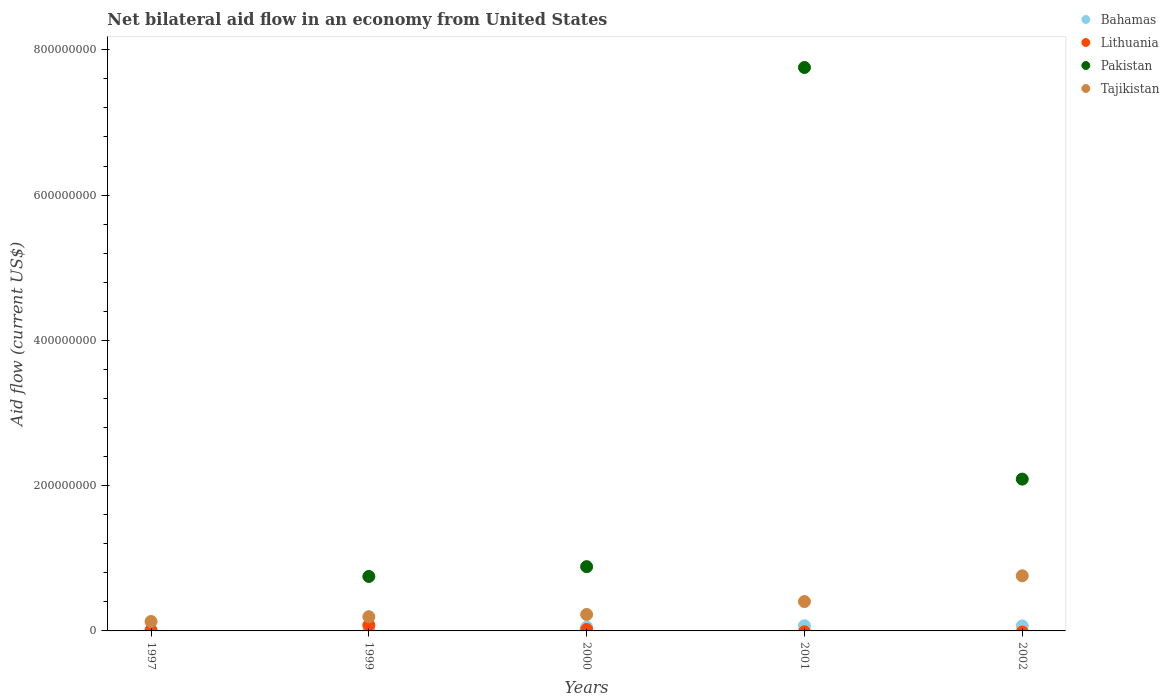Is the number of dotlines equal to the number of legend labels?
Give a very brief answer. No. What is the net bilateral aid flow in Lithuania in 2001?
Give a very brief answer. 0. Across all years, what is the maximum net bilateral aid flow in Lithuania?
Ensure brevity in your answer.  7.81e+06. Across all years, what is the minimum net bilateral aid flow in Pakistan?
Provide a succinct answer. 0. What is the total net bilateral aid flow in Bahamas in the graph?
Provide a short and direct response. 2.10e+07. What is the difference between the net bilateral aid flow in Tajikistan in 2000 and that in 2001?
Make the answer very short. -1.78e+07. What is the difference between the net bilateral aid flow in Tajikistan in 2002 and the net bilateral aid flow in Bahamas in 1997?
Give a very brief answer. 7.49e+07. What is the average net bilateral aid flow in Pakistan per year?
Your answer should be very brief. 2.30e+08. In the year 1999, what is the difference between the net bilateral aid flow in Bahamas and net bilateral aid flow in Tajikistan?
Provide a succinct answer. -1.88e+07. What is the ratio of the net bilateral aid flow in Tajikistan in 1999 to that in 2002?
Make the answer very short. 0.26. Is the net bilateral aid flow in Tajikistan in 1997 less than that in 2001?
Give a very brief answer. Yes. Is the difference between the net bilateral aid flow in Bahamas in 1999 and 2000 greater than the difference between the net bilateral aid flow in Tajikistan in 1999 and 2000?
Make the answer very short. No. What is the difference between the highest and the second highest net bilateral aid flow in Tajikistan?
Make the answer very short. 3.55e+07. What is the difference between the highest and the lowest net bilateral aid flow in Pakistan?
Provide a short and direct response. 7.76e+08. Is it the case that in every year, the sum of the net bilateral aid flow in Tajikistan and net bilateral aid flow in Lithuania  is greater than the net bilateral aid flow in Pakistan?
Offer a terse response. No. Does the net bilateral aid flow in Bahamas monotonically increase over the years?
Ensure brevity in your answer.  No. Is the net bilateral aid flow in Pakistan strictly less than the net bilateral aid flow in Lithuania over the years?
Offer a terse response. No. Are the values on the major ticks of Y-axis written in scientific E-notation?
Provide a short and direct response. No. Does the graph contain grids?
Make the answer very short. No. How are the legend labels stacked?
Your answer should be compact. Vertical. What is the title of the graph?
Your response must be concise. Net bilateral aid flow in an economy from United States. Does "Albania" appear as one of the legend labels in the graph?
Keep it short and to the point. No. What is the label or title of the X-axis?
Your response must be concise. Years. What is the label or title of the Y-axis?
Offer a terse response. Aid flow (current US$). What is the Aid flow (current US$) of Pakistan in 1997?
Your answer should be very brief. 0. What is the Aid flow (current US$) in Tajikistan in 1997?
Offer a terse response. 1.30e+07. What is the Aid flow (current US$) of Bahamas in 1999?
Your answer should be very brief. 7.80e+05. What is the Aid flow (current US$) in Lithuania in 1999?
Ensure brevity in your answer.  7.81e+06. What is the Aid flow (current US$) in Pakistan in 1999?
Make the answer very short. 7.50e+07. What is the Aid flow (current US$) of Tajikistan in 1999?
Provide a short and direct response. 1.95e+07. What is the Aid flow (current US$) of Bahamas in 2000?
Offer a terse response. 5.18e+06. What is the Aid flow (current US$) of Lithuania in 2000?
Make the answer very short. 2.04e+06. What is the Aid flow (current US$) of Pakistan in 2000?
Give a very brief answer. 8.85e+07. What is the Aid flow (current US$) in Tajikistan in 2000?
Make the answer very short. 2.26e+07. What is the Aid flow (current US$) of Bahamas in 2001?
Keep it short and to the point. 7.13e+06. What is the Aid flow (current US$) in Lithuania in 2001?
Ensure brevity in your answer.  0. What is the Aid flow (current US$) in Pakistan in 2001?
Make the answer very short. 7.76e+08. What is the Aid flow (current US$) in Tajikistan in 2001?
Your answer should be compact. 4.04e+07. What is the Aid flow (current US$) of Bahamas in 2002?
Offer a terse response. 6.92e+06. What is the Aid flow (current US$) of Pakistan in 2002?
Give a very brief answer. 2.09e+08. What is the Aid flow (current US$) in Tajikistan in 2002?
Provide a succinct answer. 7.59e+07. Across all years, what is the maximum Aid flow (current US$) in Bahamas?
Your answer should be compact. 7.13e+06. Across all years, what is the maximum Aid flow (current US$) of Lithuania?
Provide a succinct answer. 7.81e+06. Across all years, what is the maximum Aid flow (current US$) in Pakistan?
Your answer should be compact. 7.76e+08. Across all years, what is the maximum Aid flow (current US$) in Tajikistan?
Offer a terse response. 7.59e+07. Across all years, what is the minimum Aid flow (current US$) of Bahamas?
Your response must be concise. 7.80e+05. Across all years, what is the minimum Aid flow (current US$) of Pakistan?
Make the answer very short. 0. Across all years, what is the minimum Aid flow (current US$) in Tajikistan?
Offer a terse response. 1.30e+07. What is the total Aid flow (current US$) in Bahamas in the graph?
Make the answer very short. 2.10e+07. What is the total Aid flow (current US$) of Lithuania in the graph?
Your answer should be very brief. 1.08e+07. What is the total Aid flow (current US$) of Pakistan in the graph?
Make the answer very short. 1.15e+09. What is the total Aid flow (current US$) in Tajikistan in the graph?
Ensure brevity in your answer.  1.71e+08. What is the difference between the Aid flow (current US$) of Bahamas in 1997 and that in 1999?
Give a very brief answer. 2.20e+05. What is the difference between the Aid flow (current US$) in Lithuania in 1997 and that in 1999?
Your answer should be compact. -6.81e+06. What is the difference between the Aid flow (current US$) in Tajikistan in 1997 and that in 1999?
Your response must be concise. -6.54e+06. What is the difference between the Aid flow (current US$) of Bahamas in 1997 and that in 2000?
Make the answer very short. -4.18e+06. What is the difference between the Aid flow (current US$) in Lithuania in 1997 and that in 2000?
Your answer should be compact. -1.04e+06. What is the difference between the Aid flow (current US$) of Tajikistan in 1997 and that in 2000?
Make the answer very short. -9.63e+06. What is the difference between the Aid flow (current US$) in Bahamas in 1997 and that in 2001?
Give a very brief answer. -6.13e+06. What is the difference between the Aid flow (current US$) of Tajikistan in 1997 and that in 2001?
Your response must be concise. -2.74e+07. What is the difference between the Aid flow (current US$) of Bahamas in 1997 and that in 2002?
Keep it short and to the point. -5.92e+06. What is the difference between the Aid flow (current US$) in Tajikistan in 1997 and that in 2002?
Offer a terse response. -6.29e+07. What is the difference between the Aid flow (current US$) in Bahamas in 1999 and that in 2000?
Keep it short and to the point. -4.40e+06. What is the difference between the Aid flow (current US$) in Lithuania in 1999 and that in 2000?
Your response must be concise. 5.77e+06. What is the difference between the Aid flow (current US$) in Pakistan in 1999 and that in 2000?
Provide a succinct answer. -1.35e+07. What is the difference between the Aid flow (current US$) of Tajikistan in 1999 and that in 2000?
Provide a short and direct response. -3.09e+06. What is the difference between the Aid flow (current US$) of Bahamas in 1999 and that in 2001?
Your response must be concise. -6.35e+06. What is the difference between the Aid flow (current US$) in Pakistan in 1999 and that in 2001?
Provide a short and direct response. -7.01e+08. What is the difference between the Aid flow (current US$) in Tajikistan in 1999 and that in 2001?
Offer a terse response. -2.09e+07. What is the difference between the Aid flow (current US$) of Bahamas in 1999 and that in 2002?
Your answer should be compact. -6.14e+06. What is the difference between the Aid flow (current US$) of Pakistan in 1999 and that in 2002?
Ensure brevity in your answer.  -1.34e+08. What is the difference between the Aid flow (current US$) of Tajikistan in 1999 and that in 2002?
Make the answer very short. -5.63e+07. What is the difference between the Aid flow (current US$) of Bahamas in 2000 and that in 2001?
Your response must be concise. -1.95e+06. What is the difference between the Aid flow (current US$) of Pakistan in 2000 and that in 2001?
Keep it short and to the point. -6.87e+08. What is the difference between the Aid flow (current US$) in Tajikistan in 2000 and that in 2001?
Your response must be concise. -1.78e+07. What is the difference between the Aid flow (current US$) in Bahamas in 2000 and that in 2002?
Provide a succinct answer. -1.74e+06. What is the difference between the Aid flow (current US$) in Pakistan in 2000 and that in 2002?
Offer a terse response. -1.21e+08. What is the difference between the Aid flow (current US$) of Tajikistan in 2000 and that in 2002?
Provide a short and direct response. -5.32e+07. What is the difference between the Aid flow (current US$) in Bahamas in 2001 and that in 2002?
Provide a short and direct response. 2.10e+05. What is the difference between the Aid flow (current US$) in Pakistan in 2001 and that in 2002?
Give a very brief answer. 5.67e+08. What is the difference between the Aid flow (current US$) of Tajikistan in 2001 and that in 2002?
Your answer should be very brief. -3.55e+07. What is the difference between the Aid flow (current US$) in Bahamas in 1997 and the Aid flow (current US$) in Lithuania in 1999?
Offer a very short reply. -6.81e+06. What is the difference between the Aid flow (current US$) of Bahamas in 1997 and the Aid flow (current US$) of Pakistan in 1999?
Your answer should be very brief. -7.40e+07. What is the difference between the Aid flow (current US$) of Bahamas in 1997 and the Aid flow (current US$) of Tajikistan in 1999?
Provide a short and direct response. -1.85e+07. What is the difference between the Aid flow (current US$) in Lithuania in 1997 and the Aid flow (current US$) in Pakistan in 1999?
Provide a short and direct response. -7.40e+07. What is the difference between the Aid flow (current US$) in Lithuania in 1997 and the Aid flow (current US$) in Tajikistan in 1999?
Ensure brevity in your answer.  -1.85e+07. What is the difference between the Aid flow (current US$) of Bahamas in 1997 and the Aid flow (current US$) of Lithuania in 2000?
Provide a succinct answer. -1.04e+06. What is the difference between the Aid flow (current US$) of Bahamas in 1997 and the Aid flow (current US$) of Pakistan in 2000?
Your answer should be compact. -8.75e+07. What is the difference between the Aid flow (current US$) in Bahamas in 1997 and the Aid flow (current US$) in Tajikistan in 2000?
Provide a succinct answer. -2.16e+07. What is the difference between the Aid flow (current US$) of Lithuania in 1997 and the Aid flow (current US$) of Pakistan in 2000?
Offer a terse response. -8.75e+07. What is the difference between the Aid flow (current US$) of Lithuania in 1997 and the Aid flow (current US$) of Tajikistan in 2000?
Ensure brevity in your answer.  -2.16e+07. What is the difference between the Aid flow (current US$) in Bahamas in 1997 and the Aid flow (current US$) in Pakistan in 2001?
Ensure brevity in your answer.  -7.75e+08. What is the difference between the Aid flow (current US$) in Bahamas in 1997 and the Aid flow (current US$) in Tajikistan in 2001?
Provide a succinct answer. -3.94e+07. What is the difference between the Aid flow (current US$) in Lithuania in 1997 and the Aid flow (current US$) in Pakistan in 2001?
Offer a very short reply. -7.75e+08. What is the difference between the Aid flow (current US$) in Lithuania in 1997 and the Aid flow (current US$) in Tajikistan in 2001?
Keep it short and to the point. -3.94e+07. What is the difference between the Aid flow (current US$) in Bahamas in 1997 and the Aid flow (current US$) in Pakistan in 2002?
Your answer should be compact. -2.08e+08. What is the difference between the Aid flow (current US$) of Bahamas in 1997 and the Aid flow (current US$) of Tajikistan in 2002?
Make the answer very short. -7.49e+07. What is the difference between the Aid flow (current US$) of Lithuania in 1997 and the Aid flow (current US$) of Pakistan in 2002?
Offer a very short reply. -2.08e+08. What is the difference between the Aid flow (current US$) in Lithuania in 1997 and the Aid flow (current US$) in Tajikistan in 2002?
Provide a succinct answer. -7.49e+07. What is the difference between the Aid flow (current US$) of Bahamas in 1999 and the Aid flow (current US$) of Lithuania in 2000?
Your answer should be very brief. -1.26e+06. What is the difference between the Aid flow (current US$) of Bahamas in 1999 and the Aid flow (current US$) of Pakistan in 2000?
Your answer should be very brief. -8.77e+07. What is the difference between the Aid flow (current US$) of Bahamas in 1999 and the Aid flow (current US$) of Tajikistan in 2000?
Your response must be concise. -2.18e+07. What is the difference between the Aid flow (current US$) of Lithuania in 1999 and the Aid flow (current US$) of Pakistan in 2000?
Provide a succinct answer. -8.06e+07. What is the difference between the Aid flow (current US$) of Lithuania in 1999 and the Aid flow (current US$) of Tajikistan in 2000?
Your answer should be compact. -1.48e+07. What is the difference between the Aid flow (current US$) in Pakistan in 1999 and the Aid flow (current US$) in Tajikistan in 2000?
Your answer should be very brief. 5.23e+07. What is the difference between the Aid flow (current US$) of Bahamas in 1999 and the Aid flow (current US$) of Pakistan in 2001?
Make the answer very short. -7.75e+08. What is the difference between the Aid flow (current US$) of Bahamas in 1999 and the Aid flow (current US$) of Tajikistan in 2001?
Keep it short and to the point. -3.96e+07. What is the difference between the Aid flow (current US$) of Lithuania in 1999 and the Aid flow (current US$) of Pakistan in 2001?
Give a very brief answer. -7.68e+08. What is the difference between the Aid flow (current US$) of Lithuania in 1999 and the Aid flow (current US$) of Tajikistan in 2001?
Your response must be concise. -3.26e+07. What is the difference between the Aid flow (current US$) of Pakistan in 1999 and the Aid flow (current US$) of Tajikistan in 2001?
Provide a succinct answer. 3.46e+07. What is the difference between the Aid flow (current US$) in Bahamas in 1999 and the Aid flow (current US$) in Pakistan in 2002?
Make the answer very short. -2.08e+08. What is the difference between the Aid flow (current US$) of Bahamas in 1999 and the Aid flow (current US$) of Tajikistan in 2002?
Offer a very short reply. -7.51e+07. What is the difference between the Aid flow (current US$) of Lithuania in 1999 and the Aid flow (current US$) of Pakistan in 2002?
Offer a terse response. -2.01e+08. What is the difference between the Aid flow (current US$) in Lithuania in 1999 and the Aid flow (current US$) in Tajikistan in 2002?
Your answer should be very brief. -6.81e+07. What is the difference between the Aid flow (current US$) in Pakistan in 1999 and the Aid flow (current US$) in Tajikistan in 2002?
Your response must be concise. -9.10e+05. What is the difference between the Aid flow (current US$) in Bahamas in 2000 and the Aid flow (current US$) in Pakistan in 2001?
Provide a succinct answer. -7.70e+08. What is the difference between the Aid flow (current US$) in Bahamas in 2000 and the Aid flow (current US$) in Tajikistan in 2001?
Keep it short and to the point. -3.52e+07. What is the difference between the Aid flow (current US$) of Lithuania in 2000 and the Aid flow (current US$) of Pakistan in 2001?
Provide a succinct answer. -7.74e+08. What is the difference between the Aid flow (current US$) in Lithuania in 2000 and the Aid flow (current US$) in Tajikistan in 2001?
Your answer should be very brief. -3.84e+07. What is the difference between the Aid flow (current US$) in Pakistan in 2000 and the Aid flow (current US$) in Tajikistan in 2001?
Offer a very short reply. 4.80e+07. What is the difference between the Aid flow (current US$) in Bahamas in 2000 and the Aid flow (current US$) in Pakistan in 2002?
Provide a short and direct response. -2.04e+08. What is the difference between the Aid flow (current US$) in Bahamas in 2000 and the Aid flow (current US$) in Tajikistan in 2002?
Your response must be concise. -7.07e+07. What is the difference between the Aid flow (current US$) of Lithuania in 2000 and the Aid flow (current US$) of Pakistan in 2002?
Offer a terse response. -2.07e+08. What is the difference between the Aid flow (current US$) in Lithuania in 2000 and the Aid flow (current US$) in Tajikistan in 2002?
Make the answer very short. -7.38e+07. What is the difference between the Aid flow (current US$) of Pakistan in 2000 and the Aid flow (current US$) of Tajikistan in 2002?
Your answer should be very brief. 1.26e+07. What is the difference between the Aid flow (current US$) of Bahamas in 2001 and the Aid flow (current US$) of Pakistan in 2002?
Give a very brief answer. -2.02e+08. What is the difference between the Aid flow (current US$) in Bahamas in 2001 and the Aid flow (current US$) in Tajikistan in 2002?
Keep it short and to the point. -6.88e+07. What is the difference between the Aid flow (current US$) of Pakistan in 2001 and the Aid flow (current US$) of Tajikistan in 2002?
Give a very brief answer. 7.00e+08. What is the average Aid flow (current US$) of Bahamas per year?
Your answer should be compact. 4.20e+06. What is the average Aid flow (current US$) in Lithuania per year?
Provide a short and direct response. 2.17e+06. What is the average Aid flow (current US$) of Pakistan per year?
Make the answer very short. 2.30e+08. What is the average Aid flow (current US$) of Tajikistan per year?
Keep it short and to the point. 3.43e+07. In the year 1997, what is the difference between the Aid flow (current US$) of Bahamas and Aid flow (current US$) of Lithuania?
Your answer should be compact. 0. In the year 1997, what is the difference between the Aid flow (current US$) in Bahamas and Aid flow (current US$) in Tajikistan?
Ensure brevity in your answer.  -1.20e+07. In the year 1997, what is the difference between the Aid flow (current US$) in Lithuania and Aid flow (current US$) in Tajikistan?
Provide a succinct answer. -1.20e+07. In the year 1999, what is the difference between the Aid flow (current US$) of Bahamas and Aid flow (current US$) of Lithuania?
Keep it short and to the point. -7.03e+06. In the year 1999, what is the difference between the Aid flow (current US$) of Bahamas and Aid flow (current US$) of Pakistan?
Offer a very short reply. -7.42e+07. In the year 1999, what is the difference between the Aid flow (current US$) of Bahamas and Aid flow (current US$) of Tajikistan?
Your answer should be very brief. -1.88e+07. In the year 1999, what is the difference between the Aid flow (current US$) in Lithuania and Aid flow (current US$) in Pakistan?
Offer a terse response. -6.72e+07. In the year 1999, what is the difference between the Aid flow (current US$) of Lithuania and Aid flow (current US$) of Tajikistan?
Provide a short and direct response. -1.17e+07. In the year 1999, what is the difference between the Aid flow (current US$) in Pakistan and Aid flow (current US$) in Tajikistan?
Offer a very short reply. 5.54e+07. In the year 2000, what is the difference between the Aid flow (current US$) in Bahamas and Aid flow (current US$) in Lithuania?
Make the answer very short. 3.14e+06. In the year 2000, what is the difference between the Aid flow (current US$) in Bahamas and Aid flow (current US$) in Pakistan?
Provide a succinct answer. -8.33e+07. In the year 2000, what is the difference between the Aid flow (current US$) in Bahamas and Aid flow (current US$) in Tajikistan?
Make the answer very short. -1.74e+07. In the year 2000, what is the difference between the Aid flow (current US$) of Lithuania and Aid flow (current US$) of Pakistan?
Give a very brief answer. -8.64e+07. In the year 2000, what is the difference between the Aid flow (current US$) of Lithuania and Aid flow (current US$) of Tajikistan?
Your answer should be compact. -2.06e+07. In the year 2000, what is the difference between the Aid flow (current US$) of Pakistan and Aid flow (current US$) of Tajikistan?
Offer a very short reply. 6.58e+07. In the year 2001, what is the difference between the Aid flow (current US$) of Bahamas and Aid flow (current US$) of Pakistan?
Ensure brevity in your answer.  -7.69e+08. In the year 2001, what is the difference between the Aid flow (current US$) in Bahamas and Aid flow (current US$) in Tajikistan?
Give a very brief answer. -3.33e+07. In the year 2001, what is the difference between the Aid flow (current US$) of Pakistan and Aid flow (current US$) of Tajikistan?
Keep it short and to the point. 7.35e+08. In the year 2002, what is the difference between the Aid flow (current US$) in Bahamas and Aid flow (current US$) in Pakistan?
Offer a very short reply. -2.02e+08. In the year 2002, what is the difference between the Aid flow (current US$) in Bahamas and Aid flow (current US$) in Tajikistan?
Your answer should be compact. -6.90e+07. In the year 2002, what is the difference between the Aid flow (current US$) in Pakistan and Aid flow (current US$) in Tajikistan?
Offer a terse response. 1.33e+08. What is the ratio of the Aid flow (current US$) of Bahamas in 1997 to that in 1999?
Your response must be concise. 1.28. What is the ratio of the Aid flow (current US$) of Lithuania in 1997 to that in 1999?
Give a very brief answer. 0.13. What is the ratio of the Aid flow (current US$) in Tajikistan in 1997 to that in 1999?
Offer a terse response. 0.67. What is the ratio of the Aid flow (current US$) of Bahamas in 1997 to that in 2000?
Your answer should be very brief. 0.19. What is the ratio of the Aid flow (current US$) of Lithuania in 1997 to that in 2000?
Offer a very short reply. 0.49. What is the ratio of the Aid flow (current US$) of Tajikistan in 1997 to that in 2000?
Give a very brief answer. 0.57. What is the ratio of the Aid flow (current US$) in Bahamas in 1997 to that in 2001?
Your response must be concise. 0.14. What is the ratio of the Aid flow (current US$) in Tajikistan in 1997 to that in 2001?
Keep it short and to the point. 0.32. What is the ratio of the Aid flow (current US$) of Bahamas in 1997 to that in 2002?
Keep it short and to the point. 0.14. What is the ratio of the Aid flow (current US$) in Tajikistan in 1997 to that in 2002?
Your response must be concise. 0.17. What is the ratio of the Aid flow (current US$) of Bahamas in 1999 to that in 2000?
Make the answer very short. 0.15. What is the ratio of the Aid flow (current US$) in Lithuania in 1999 to that in 2000?
Make the answer very short. 3.83. What is the ratio of the Aid flow (current US$) of Pakistan in 1999 to that in 2000?
Provide a short and direct response. 0.85. What is the ratio of the Aid flow (current US$) of Tajikistan in 1999 to that in 2000?
Make the answer very short. 0.86. What is the ratio of the Aid flow (current US$) in Bahamas in 1999 to that in 2001?
Provide a succinct answer. 0.11. What is the ratio of the Aid flow (current US$) in Pakistan in 1999 to that in 2001?
Provide a short and direct response. 0.1. What is the ratio of the Aid flow (current US$) in Tajikistan in 1999 to that in 2001?
Your answer should be compact. 0.48. What is the ratio of the Aid flow (current US$) in Bahamas in 1999 to that in 2002?
Your answer should be compact. 0.11. What is the ratio of the Aid flow (current US$) of Pakistan in 1999 to that in 2002?
Offer a terse response. 0.36. What is the ratio of the Aid flow (current US$) in Tajikistan in 1999 to that in 2002?
Give a very brief answer. 0.26. What is the ratio of the Aid flow (current US$) of Bahamas in 2000 to that in 2001?
Make the answer very short. 0.73. What is the ratio of the Aid flow (current US$) in Pakistan in 2000 to that in 2001?
Give a very brief answer. 0.11. What is the ratio of the Aid flow (current US$) in Tajikistan in 2000 to that in 2001?
Your response must be concise. 0.56. What is the ratio of the Aid flow (current US$) in Bahamas in 2000 to that in 2002?
Ensure brevity in your answer.  0.75. What is the ratio of the Aid flow (current US$) of Pakistan in 2000 to that in 2002?
Provide a succinct answer. 0.42. What is the ratio of the Aid flow (current US$) of Tajikistan in 2000 to that in 2002?
Your response must be concise. 0.3. What is the ratio of the Aid flow (current US$) in Bahamas in 2001 to that in 2002?
Your answer should be very brief. 1.03. What is the ratio of the Aid flow (current US$) in Pakistan in 2001 to that in 2002?
Make the answer very short. 3.71. What is the ratio of the Aid flow (current US$) of Tajikistan in 2001 to that in 2002?
Offer a terse response. 0.53. What is the difference between the highest and the second highest Aid flow (current US$) in Lithuania?
Provide a succinct answer. 5.77e+06. What is the difference between the highest and the second highest Aid flow (current US$) in Pakistan?
Offer a very short reply. 5.67e+08. What is the difference between the highest and the second highest Aid flow (current US$) in Tajikistan?
Provide a succinct answer. 3.55e+07. What is the difference between the highest and the lowest Aid flow (current US$) of Bahamas?
Keep it short and to the point. 6.35e+06. What is the difference between the highest and the lowest Aid flow (current US$) in Lithuania?
Your response must be concise. 7.81e+06. What is the difference between the highest and the lowest Aid flow (current US$) in Pakistan?
Make the answer very short. 7.76e+08. What is the difference between the highest and the lowest Aid flow (current US$) in Tajikistan?
Provide a succinct answer. 6.29e+07. 